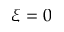Convert formula to latex. <formula><loc_0><loc_0><loc_500><loc_500>\xi = 0</formula> 